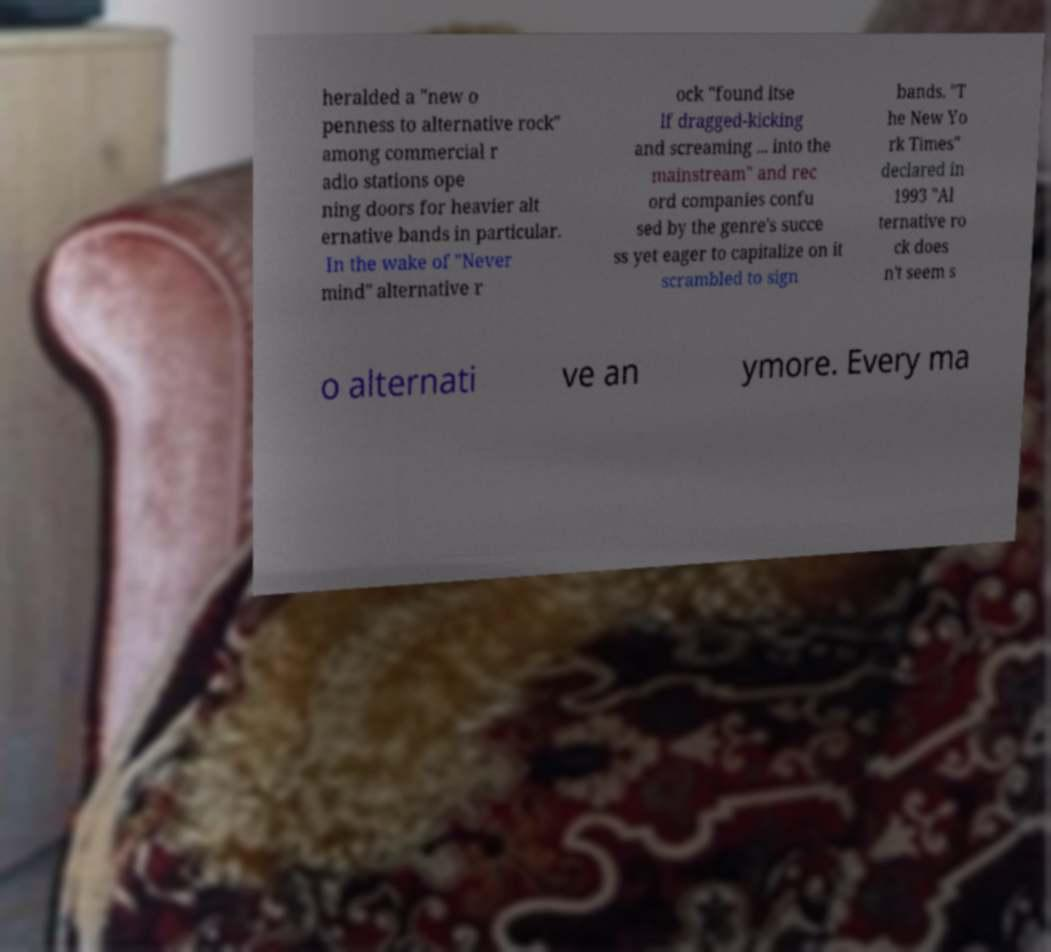Please identify and transcribe the text found in this image. heralded a "new o penness to alternative rock" among commercial r adio stations ope ning doors for heavier alt ernative bands in particular. In the wake of "Never mind" alternative r ock "found itse lf dragged-kicking and screaming ... into the mainstream" and rec ord companies confu sed by the genre's succe ss yet eager to capitalize on it scrambled to sign bands. "T he New Yo rk Times" declared in 1993 "Al ternative ro ck does n't seem s o alternati ve an ymore. Every ma 